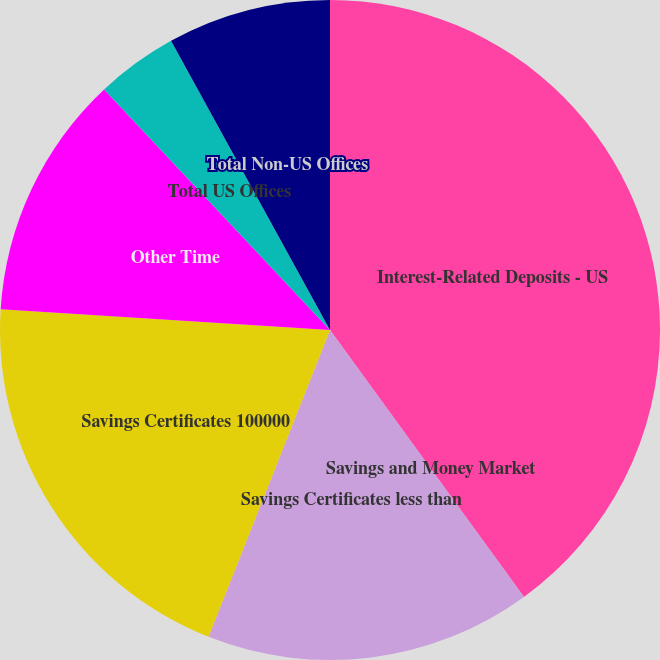Convert chart to OTSL. <chart><loc_0><loc_0><loc_500><loc_500><pie_chart><fcel>Interest-Related Deposits - US<fcel>Savings and Money Market<fcel>Savings Certificates less than<fcel>Savings Certificates 100000<fcel>Other Time<fcel>Total US Offices<fcel>Total Non-US Offices<nl><fcel>40.0%<fcel>0.0%<fcel>16.0%<fcel>20.0%<fcel>12.0%<fcel>4.0%<fcel>8.0%<nl></chart> 